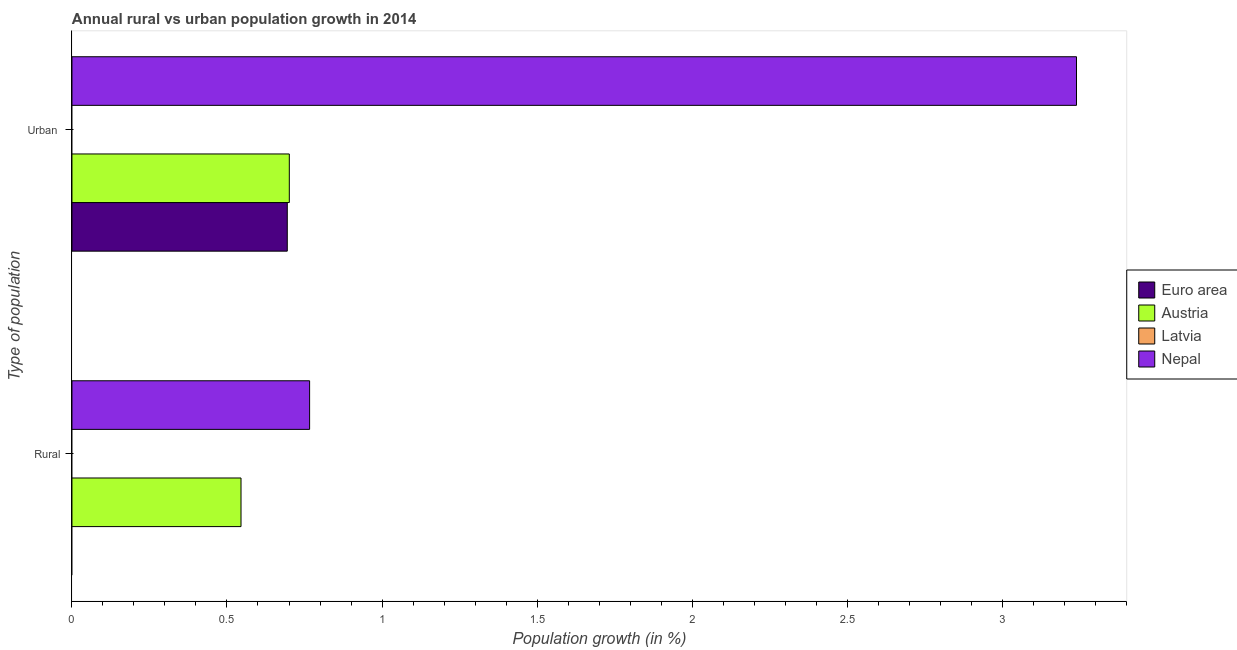Are the number of bars per tick equal to the number of legend labels?
Ensure brevity in your answer.  No. How many bars are there on the 2nd tick from the top?
Make the answer very short. 2. What is the label of the 2nd group of bars from the top?
Your response must be concise. Rural. What is the urban population growth in Euro area?
Make the answer very short. 0.69. Across all countries, what is the maximum rural population growth?
Ensure brevity in your answer.  0.77. Across all countries, what is the minimum rural population growth?
Ensure brevity in your answer.  0. In which country was the rural population growth maximum?
Ensure brevity in your answer.  Nepal. What is the total rural population growth in the graph?
Keep it short and to the point. 1.31. What is the difference between the rural population growth in Nepal and that in Austria?
Provide a short and direct response. 0.22. What is the difference between the urban population growth in Austria and the rural population growth in Euro area?
Offer a very short reply. 0.7. What is the average urban population growth per country?
Offer a very short reply. 1.16. What is the difference between the urban population growth and rural population growth in Nepal?
Your response must be concise. 2.47. In how many countries, is the rural population growth greater than 2.3 %?
Ensure brevity in your answer.  0. How many bars are there?
Provide a short and direct response. 5. Are all the bars in the graph horizontal?
Your response must be concise. Yes. How many countries are there in the graph?
Ensure brevity in your answer.  4. What is the difference between two consecutive major ticks on the X-axis?
Your response must be concise. 0.5. Does the graph contain grids?
Give a very brief answer. No. How are the legend labels stacked?
Your answer should be compact. Vertical. What is the title of the graph?
Keep it short and to the point. Annual rural vs urban population growth in 2014. Does "Switzerland" appear as one of the legend labels in the graph?
Offer a very short reply. No. What is the label or title of the X-axis?
Your answer should be very brief. Population growth (in %). What is the label or title of the Y-axis?
Provide a succinct answer. Type of population. What is the Population growth (in %) in Euro area in Rural?
Give a very brief answer. 0. What is the Population growth (in %) of Austria in Rural?
Your answer should be compact. 0.55. What is the Population growth (in %) of Latvia in Rural?
Keep it short and to the point. 0. What is the Population growth (in %) of Nepal in Rural?
Provide a succinct answer. 0.77. What is the Population growth (in %) of Euro area in Urban ?
Your response must be concise. 0.69. What is the Population growth (in %) of Austria in Urban ?
Provide a short and direct response. 0.7. What is the Population growth (in %) in Latvia in Urban ?
Provide a succinct answer. 0. What is the Population growth (in %) in Nepal in Urban ?
Provide a succinct answer. 3.24. Across all Type of population, what is the maximum Population growth (in %) in Euro area?
Offer a terse response. 0.69. Across all Type of population, what is the maximum Population growth (in %) of Austria?
Give a very brief answer. 0.7. Across all Type of population, what is the maximum Population growth (in %) in Nepal?
Offer a terse response. 3.24. Across all Type of population, what is the minimum Population growth (in %) of Euro area?
Give a very brief answer. 0. Across all Type of population, what is the minimum Population growth (in %) in Austria?
Provide a succinct answer. 0.55. Across all Type of population, what is the minimum Population growth (in %) of Nepal?
Provide a short and direct response. 0.77. What is the total Population growth (in %) in Euro area in the graph?
Keep it short and to the point. 0.69. What is the total Population growth (in %) in Austria in the graph?
Make the answer very short. 1.25. What is the total Population growth (in %) in Nepal in the graph?
Offer a terse response. 4.01. What is the difference between the Population growth (in %) of Austria in Rural and that in Urban ?
Offer a terse response. -0.16. What is the difference between the Population growth (in %) in Nepal in Rural and that in Urban ?
Give a very brief answer. -2.47. What is the difference between the Population growth (in %) of Austria in Rural and the Population growth (in %) of Nepal in Urban ?
Your answer should be very brief. -2.69. What is the average Population growth (in %) in Euro area per Type of population?
Offer a terse response. 0.35. What is the average Population growth (in %) of Austria per Type of population?
Your response must be concise. 0.62. What is the average Population growth (in %) in Latvia per Type of population?
Give a very brief answer. 0. What is the average Population growth (in %) in Nepal per Type of population?
Provide a succinct answer. 2. What is the difference between the Population growth (in %) of Austria and Population growth (in %) of Nepal in Rural?
Ensure brevity in your answer.  -0.22. What is the difference between the Population growth (in %) in Euro area and Population growth (in %) in Austria in Urban ?
Offer a terse response. -0.01. What is the difference between the Population growth (in %) in Euro area and Population growth (in %) in Nepal in Urban ?
Your answer should be compact. -2.55. What is the difference between the Population growth (in %) of Austria and Population growth (in %) of Nepal in Urban ?
Keep it short and to the point. -2.54. What is the ratio of the Population growth (in %) in Austria in Rural to that in Urban ?
Offer a very short reply. 0.78. What is the ratio of the Population growth (in %) in Nepal in Rural to that in Urban ?
Give a very brief answer. 0.24. What is the difference between the highest and the second highest Population growth (in %) of Austria?
Your response must be concise. 0.16. What is the difference between the highest and the second highest Population growth (in %) of Nepal?
Provide a succinct answer. 2.47. What is the difference between the highest and the lowest Population growth (in %) of Euro area?
Give a very brief answer. 0.69. What is the difference between the highest and the lowest Population growth (in %) in Austria?
Your answer should be very brief. 0.16. What is the difference between the highest and the lowest Population growth (in %) in Nepal?
Ensure brevity in your answer.  2.47. 